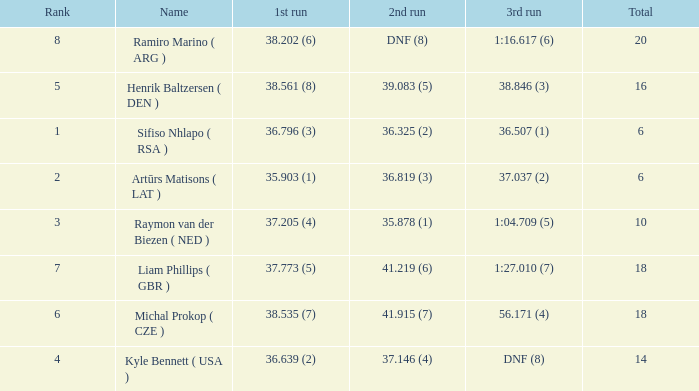Which 3rd run has rank of 8? 1:16.617 (6). 